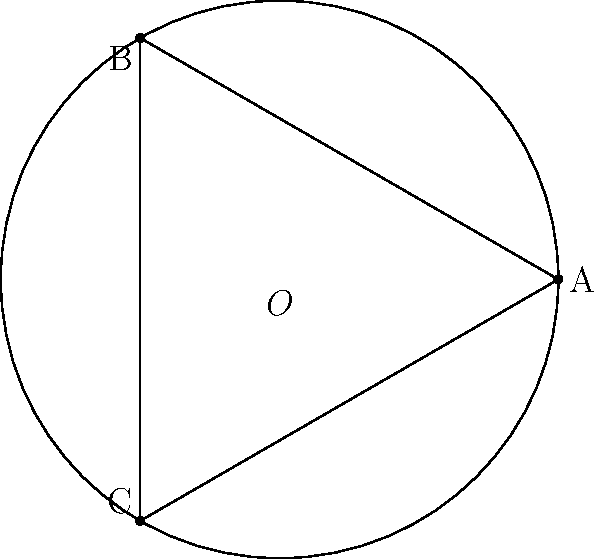In a hyperbolic plane, an equilateral triangle ABC is inscribed in a circle with center O. If the sum of the interior angles of the triangle is 150°, what is the area of the triangle in terms of the radius r of the circle? To solve this problem, we need to follow these steps:

1) In hyperbolic geometry, the sum of the interior angles of a triangle is always less than 180°. The difference between 180° and the actual sum is called the defect.

2) In this case, the sum of the interior angles is 150°, so the defect is:
   $$\text{Defect} = 180° - 150° = 30°$$

3) In hyperbolic geometry, the area of a triangle is directly proportional to its defect. The formula is:
   $$\text{Area} = R^2 \cdot \text{Defect (in radians)}$$
   where R is the radius of curvature of the hyperbolic plane.

4) We need to convert the defect from degrees to radians:
   $$30° = \frac{30 \cdot \pi}{180} = \frac{\pi}{6} \text{ radians}$$

5) Now, we can substitute this into the area formula:
   $$\text{Area} = R^2 \cdot \frac{\pi}{6}$$

6) However, the question asks for the area in terms of the radius r of the circle, not the radius of curvature R. In hyperbolic geometry, these are not the same.

7) For a circle in hyperbolic geometry, the relationship between its radius r and the radius of curvature R is:
   $$R = \frac{r}{\tanh(r/R)}$$

8) Substituting this into our area formula:
   $$\text{Area} = \left(\frac{r}{\tanh(r/R)}\right)^2 \cdot \frac{\pi}{6}$$

This is the exact expression for the area. However, for small r (relative to R), we can approximate tanh(r/R) ≈ r/R, which gives us the simpler approximation:

$$\text{Area} \approx \frac{\pi r^2}{6}$$

This approximation becomes more accurate as r becomes smaller compared to R.
Answer: $\left(\frac{r}{\tanh(r/R)}\right)^2 \cdot \frac{\pi}{6}$, or approximately $\frac{\pi r^2}{6}$ for small r 